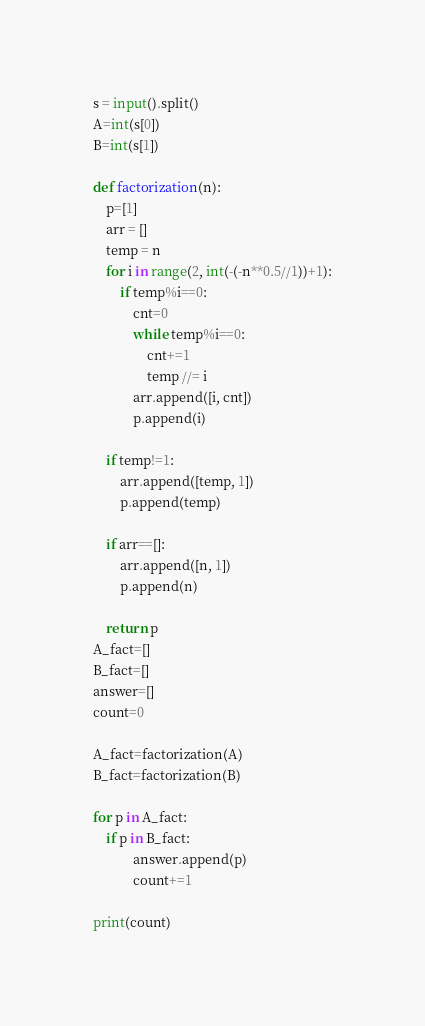Convert code to text. <code><loc_0><loc_0><loc_500><loc_500><_Python_>s = input().split()
A=int(s[0])
B=int(s[1])

def factorization(n):
    p=[1]
    arr = []
    temp = n
    for i in range(2, int(-(-n**0.5//1))+1):
        if temp%i==0:
            cnt=0
            while temp%i==0:
                cnt+=1
                temp //= i
            arr.append([i, cnt])
            p.append(i)

    if temp!=1:
        arr.append([temp, 1])
        p.append(temp)

    if arr==[]:
        arr.append([n, 1])
        p.append(n)

    return p
A_fact=[]
B_fact=[]
answer=[]
count=0

A_fact=factorization(A)
B_fact=factorization(B)

for p in A_fact:
    if p in B_fact:
            answer.append(p)
            count+=1

print(count)
</code> 